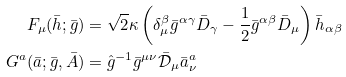<formula> <loc_0><loc_0><loc_500><loc_500>F _ { \mu } ( \bar { h } ; \bar { g } ) & = \sqrt { 2 } \kappa \left ( \delta _ { \mu } ^ { \beta } \bar { g } ^ { \alpha \gamma } \bar { D } _ { \gamma } - \frac { 1 } { 2 } \bar { g } ^ { \alpha \beta } \bar { D } _ { \mu } \right ) \bar { h } _ { \alpha \beta } \\ G ^ { a } ( \bar { a } ; \bar { g } , \bar { A } ) & = \hat { g } ^ { - 1 } \bar { g } ^ { \mu \nu } \bar { \mathcal { D } } _ { \mu } \bar { a } ^ { a } _ { \nu }</formula> 